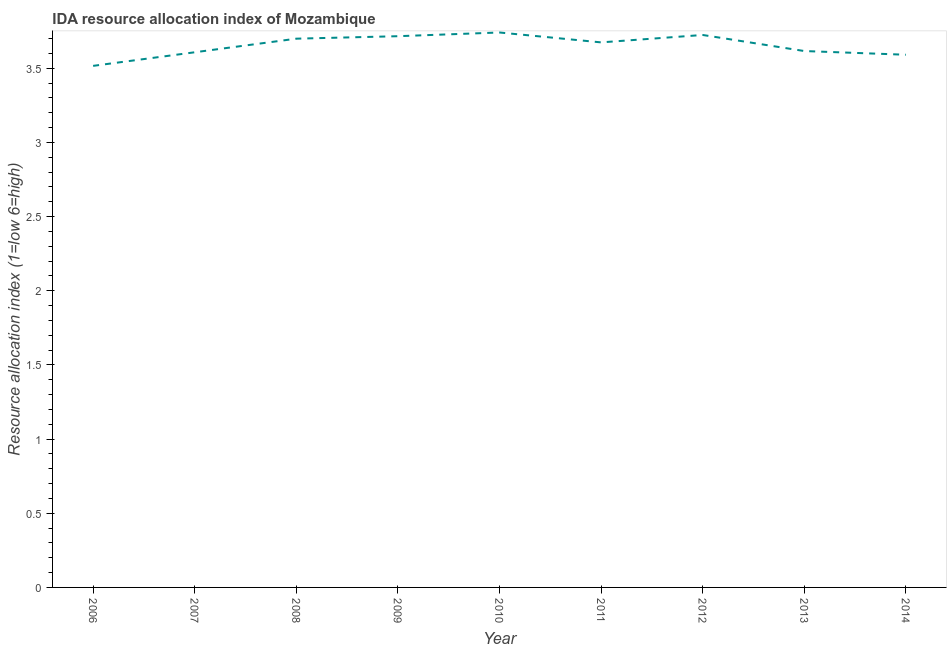What is the ida resource allocation index in 2012?
Offer a very short reply. 3.73. Across all years, what is the maximum ida resource allocation index?
Your answer should be very brief. 3.74. Across all years, what is the minimum ida resource allocation index?
Offer a very short reply. 3.52. In which year was the ida resource allocation index maximum?
Provide a short and direct response. 2010. What is the sum of the ida resource allocation index?
Offer a terse response. 32.89. What is the difference between the ida resource allocation index in 2008 and 2014?
Offer a terse response. 0.11. What is the average ida resource allocation index per year?
Your answer should be compact. 3.65. What is the median ida resource allocation index?
Your answer should be compact. 3.67. In how many years, is the ida resource allocation index greater than 2.9 ?
Your answer should be compact. 9. Do a majority of the years between 2006 and 2008 (inclusive) have ida resource allocation index greater than 1.9 ?
Provide a succinct answer. Yes. What is the ratio of the ida resource allocation index in 2012 to that in 2013?
Your answer should be compact. 1.03. Is the ida resource allocation index in 2009 less than that in 2010?
Provide a short and direct response. Yes. What is the difference between the highest and the second highest ida resource allocation index?
Give a very brief answer. 0.02. Is the sum of the ida resource allocation index in 2012 and 2013 greater than the maximum ida resource allocation index across all years?
Give a very brief answer. Yes. What is the difference between the highest and the lowest ida resource allocation index?
Make the answer very short. 0.22. In how many years, is the ida resource allocation index greater than the average ida resource allocation index taken over all years?
Your answer should be very brief. 5. Does the ida resource allocation index monotonically increase over the years?
Your response must be concise. No. How many lines are there?
Keep it short and to the point. 1. How many years are there in the graph?
Ensure brevity in your answer.  9. What is the difference between two consecutive major ticks on the Y-axis?
Your answer should be compact. 0.5. Does the graph contain grids?
Offer a very short reply. No. What is the title of the graph?
Your answer should be compact. IDA resource allocation index of Mozambique. What is the label or title of the X-axis?
Your response must be concise. Year. What is the label or title of the Y-axis?
Ensure brevity in your answer.  Resource allocation index (1=low 6=high). What is the Resource allocation index (1=low 6=high) in 2006?
Provide a succinct answer. 3.52. What is the Resource allocation index (1=low 6=high) in 2007?
Offer a terse response. 3.61. What is the Resource allocation index (1=low 6=high) in 2008?
Keep it short and to the point. 3.7. What is the Resource allocation index (1=low 6=high) in 2009?
Keep it short and to the point. 3.72. What is the Resource allocation index (1=low 6=high) in 2010?
Your answer should be compact. 3.74. What is the Resource allocation index (1=low 6=high) in 2011?
Provide a succinct answer. 3.67. What is the Resource allocation index (1=low 6=high) in 2012?
Provide a short and direct response. 3.73. What is the Resource allocation index (1=low 6=high) of 2013?
Give a very brief answer. 3.62. What is the Resource allocation index (1=low 6=high) of 2014?
Offer a terse response. 3.59. What is the difference between the Resource allocation index (1=low 6=high) in 2006 and 2007?
Your response must be concise. -0.09. What is the difference between the Resource allocation index (1=low 6=high) in 2006 and 2008?
Ensure brevity in your answer.  -0.18. What is the difference between the Resource allocation index (1=low 6=high) in 2006 and 2009?
Offer a very short reply. -0.2. What is the difference between the Resource allocation index (1=low 6=high) in 2006 and 2010?
Ensure brevity in your answer.  -0.23. What is the difference between the Resource allocation index (1=low 6=high) in 2006 and 2011?
Give a very brief answer. -0.16. What is the difference between the Resource allocation index (1=low 6=high) in 2006 and 2012?
Provide a succinct answer. -0.21. What is the difference between the Resource allocation index (1=low 6=high) in 2006 and 2014?
Make the answer very short. -0.07. What is the difference between the Resource allocation index (1=low 6=high) in 2007 and 2008?
Your answer should be very brief. -0.09. What is the difference between the Resource allocation index (1=low 6=high) in 2007 and 2009?
Provide a succinct answer. -0.11. What is the difference between the Resource allocation index (1=low 6=high) in 2007 and 2010?
Ensure brevity in your answer.  -0.13. What is the difference between the Resource allocation index (1=low 6=high) in 2007 and 2011?
Offer a terse response. -0.07. What is the difference between the Resource allocation index (1=low 6=high) in 2007 and 2012?
Your answer should be compact. -0.12. What is the difference between the Resource allocation index (1=low 6=high) in 2007 and 2013?
Offer a terse response. -0.01. What is the difference between the Resource allocation index (1=low 6=high) in 2007 and 2014?
Provide a short and direct response. 0.02. What is the difference between the Resource allocation index (1=low 6=high) in 2008 and 2009?
Offer a very short reply. -0.02. What is the difference between the Resource allocation index (1=low 6=high) in 2008 and 2010?
Offer a terse response. -0.04. What is the difference between the Resource allocation index (1=low 6=high) in 2008 and 2011?
Provide a short and direct response. 0.03. What is the difference between the Resource allocation index (1=low 6=high) in 2008 and 2012?
Your answer should be very brief. -0.03. What is the difference between the Resource allocation index (1=low 6=high) in 2008 and 2013?
Make the answer very short. 0.08. What is the difference between the Resource allocation index (1=low 6=high) in 2008 and 2014?
Offer a very short reply. 0.11. What is the difference between the Resource allocation index (1=low 6=high) in 2009 and 2010?
Keep it short and to the point. -0.03. What is the difference between the Resource allocation index (1=low 6=high) in 2009 and 2011?
Give a very brief answer. 0.04. What is the difference between the Resource allocation index (1=low 6=high) in 2009 and 2012?
Give a very brief answer. -0.01. What is the difference between the Resource allocation index (1=low 6=high) in 2009 and 2014?
Provide a succinct answer. 0.12. What is the difference between the Resource allocation index (1=low 6=high) in 2010 and 2011?
Your answer should be compact. 0.07. What is the difference between the Resource allocation index (1=low 6=high) in 2010 and 2012?
Your answer should be compact. 0.02. What is the difference between the Resource allocation index (1=low 6=high) in 2010 and 2013?
Provide a short and direct response. 0.12. What is the difference between the Resource allocation index (1=low 6=high) in 2010 and 2014?
Make the answer very short. 0.15. What is the difference between the Resource allocation index (1=low 6=high) in 2011 and 2012?
Make the answer very short. -0.05. What is the difference between the Resource allocation index (1=low 6=high) in 2011 and 2013?
Your response must be concise. 0.06. What is the difference between the Resource allocation index (1=low 6=high) in 2011 and 2014?
Offer a terse response. 0.08. What is the difference between the Resource allocation index (1=low 6=high) in 2012 and 2013?
Your response must be concise. 0.11. What is the difference between the Resource allocation index (1=low 6=high) in 2012 and 2014?
Provide a succinct answer. 0.13. What is the difference between the Resource allocation index (1=low 6=high) in 2013 and 2014?
Offer a very short reply. 0.03. What is the ratio of the Resource allocation index (1=low 6=high) in 2006 to that in 2008?
Offer a very short reply. 0.95. What is the ratio of the Resource allocation index (1=low 6=high) in 2006 to that in 2009?
Offer a terse response. 0.95. What is the ratio of the Resource allocation index (1=low 6=high) in 2006 to that in 2010?
Offer a terse response. 0.94. What is the ratio of the Resource allocation index (1=low 6=high) in 2006 to that in 2012?
Offer a very short reply. 0.94. What is the ratio of the Resource allocation index (1=low 6=high) in 2007 to that in 2008?
Make the answer very short. 0.97. What is the ratio of the Resource allocation index (1=low 6=high) in 2007 to that in 2010?
Give a very brief answer. 0.96. What is the ratio of the Resource allocation index (1=low 6=high) in 2007 to that in 2012?
Provide a succinct answer. 0.97. What is the ratio of the Resource allocation index (1=low 6=high) in 2007 to that in 2014?
Offer a terse response. 1. What is the ratio of the Resource allocation index (1=low 6=high) in 2008 to that in 2010?
Your response must be concise. 0.99. What is the ratio of the Resource allocation index (1=low 6=high) in 2008 to that in 2013?
Provide a short and direct response. 1.02. What is the ratio of the Resource allocation index (1=low 6=high) in 2008 to that in 2014?
Offer a terse response. 1.03. What is the ratio of the Resource allocation index (1=low 6=high) in 2009 to that in 2011?
Your answer should be very brief. 1.01. What is the ratio of the Resource allocation index (1=low 6=high) in 2009 to that in 2012?
Give a very brief answer. 1. What is the ratio of the Resource allocation index (1=low 6=high) in 2009 to that in 2013?
Provide a succinct answer. 1.03. What is the ratio of the Resource allocation index (1=low 6=high) in 2009 to that in 2014?
Your answer should be very brief. 1.03. What is the ratio of the Resource allocation index (1=low 6=high) in 2010 to that in 2013?
Ensure brevity in your answer.  1.03. What is the ratio of the Resource allocation index (1=low 6=high) in 2010 to that in 2014?
Provide a succinct answer. 1.04. What is the ratio of the Resource allocation index (1=low 6=high) in 2011 to that in 2014?
Your answer should be very brief. 1.02. What is the ratio of the Resource allocation index (1=low 6=high) in 2012 to that in 2013?
Make the answer very short. 1.03. What is the ratio of the Resource allocation index (1=low 6=high) in 2012 to that in 2014?
Your answer should be very brief. 1.04. 